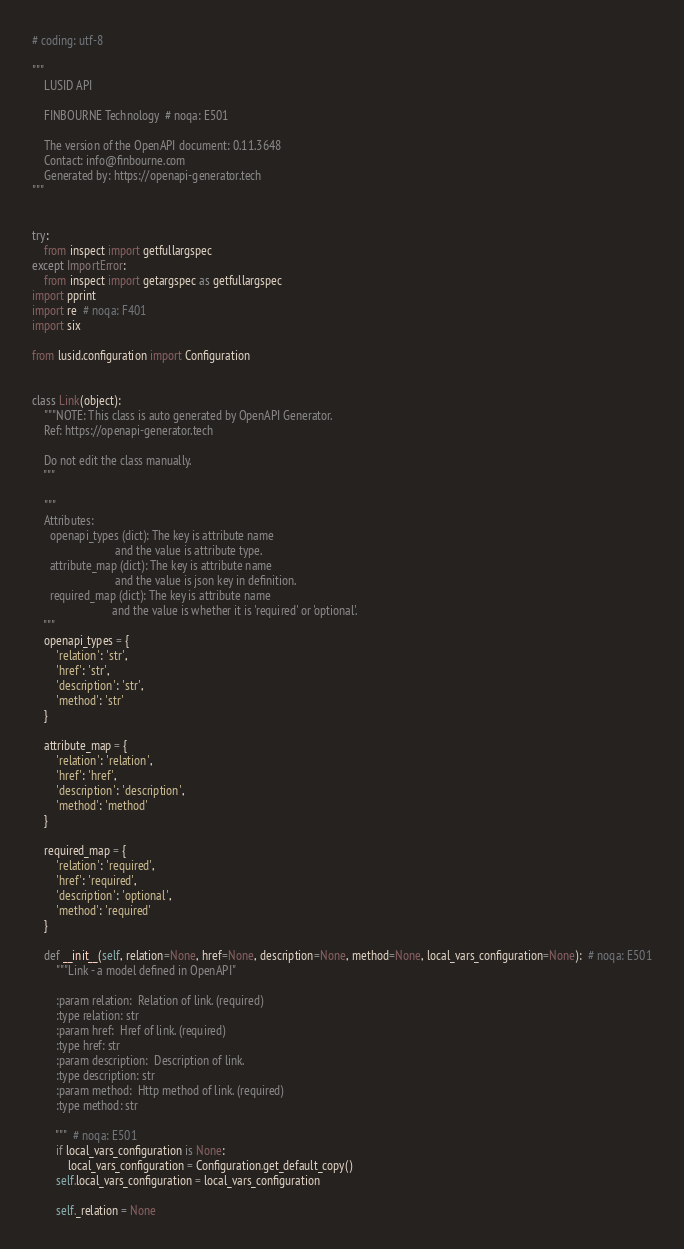<code> <loc_0><loc_0><loc_500><loc_500><_Python_># coding: utf-8

"""
    LUSID API

    FINBOURNE Technology  # noqa: E501

    The version of the OpenAPI document: 0.11.3648
    Contact: info@finbourne.com
    Generated by: https://openapi-generator.tech
"""


try:
    from inspect import getfullargspec
except ImportError:
    from inspect import getargspec as getfullargspec
import pprint
import re  # noqa: F401
import six

from lusid.configuration import Configuration


class Link(object):
    """NOTE: This class is auto generated by OpenAPI Generator.
    Ref: https://openapi-generator.tech

    Do not edit the class manually.
    """

    """
    Attributes:
      openapi_types (dict): The key is attribute name
                            and the value is attribute type.
      attribute_map (dict): The key is attribute name
                            and the value is json key in definition.
      required_map (dict): The key is attribute name
                           and the value is whether it is 'required' or 'optional'.
    """
    openapi_types = {
        'relation': 'str',
        'href': 'str',
        'description': 'str',
        'method': 'str'
    }

    attribute_map = {
        'relation': 'relation',
        'href': 'href',
        'description': 'description',
        'method': 'method'
    }

    required_map = {
        'relation': 'required',
        'href': 'required',
        'description': 'optional',
        'method': 'required'
    }

    def __init__(self, relation=None, href=None, description=None, method=None, local_vars_configuration=None):  # noqa: E501
        """Link - a model defined in OpenAPI"
        
        :param relation:  Relation of link. (required)
        :type relation: str
        :param href:  Href of link. (required)
        :type href: str
        :param description:  Description of link.
        :type description: str
        :param method:  Http method of link. (required)
        :type method: str

        """  # noqa: E501
        if local_vars_configuration is None:
            local_vars_configuration = Configuration.get_default_copy()
        self.local_vars_configuration = local_vars_configuration

        self._relation = None</code> 